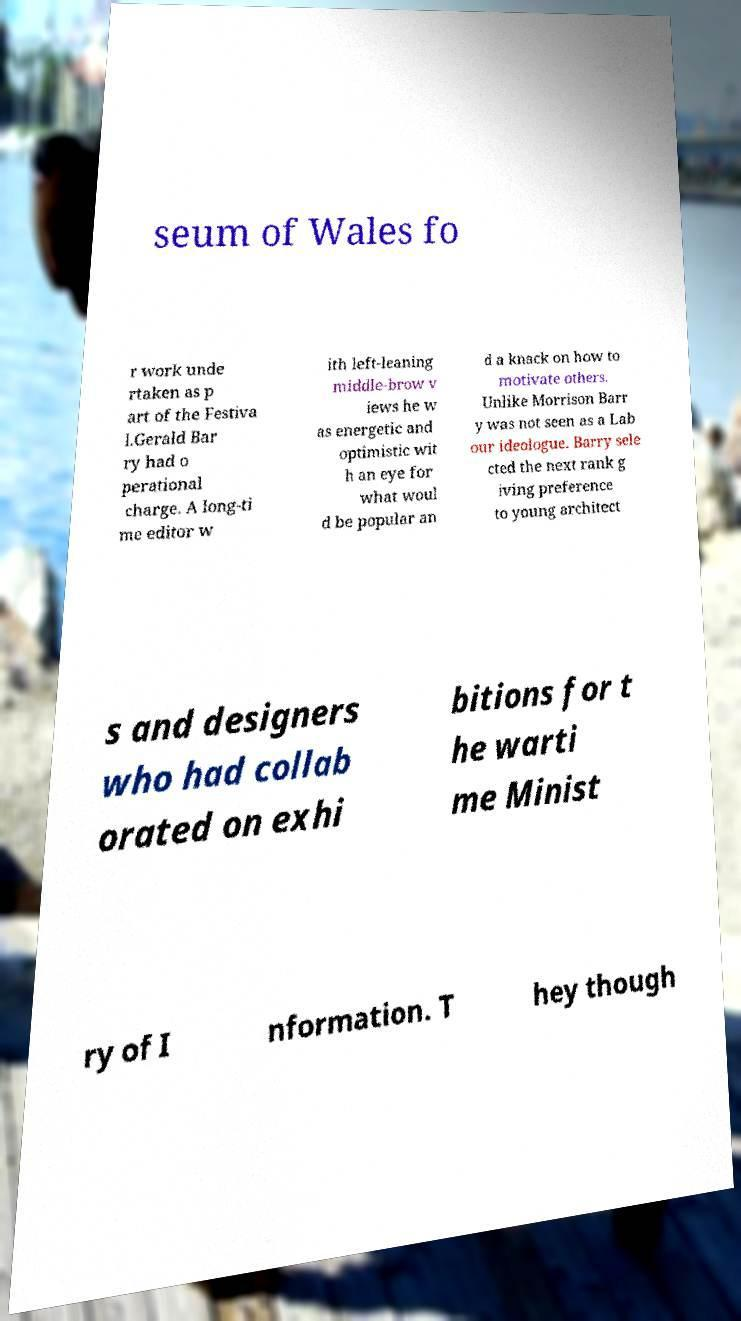I need the written content from this picture converted into text. Can you do that? seum of Wales fo r work unde rtaken as p art of the Festiva l.Gerald Bar ry had o perational charge. A long-ti me editor w ith left-leaning middle-brow v iews he w as energetic and optimistic wit h an eye for what woul d be popular an d a knack on how to motivate others. Unlike Morrison Barr y was not seen as a Lab our ideologue. Barry sele cted the next rank g iving preference to young architect s and designers who had collab orated on exhi bitions for t he warti me Minist ry of I nformation. T hey though 